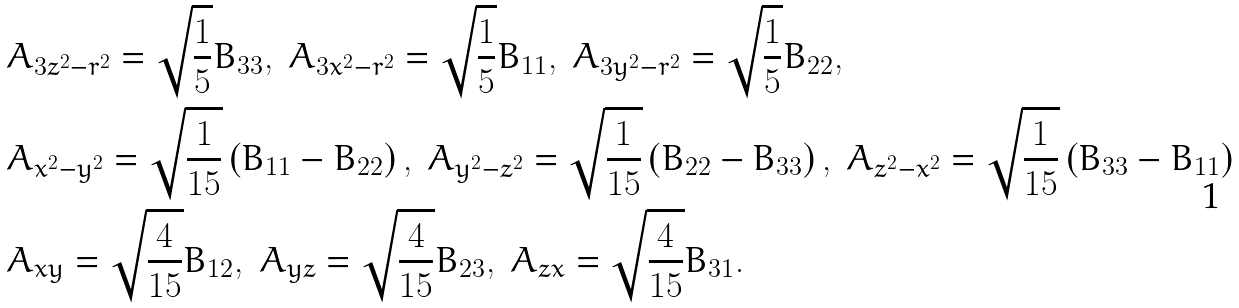<formula> <loc_0><loc_0><loc_500><loc_500>& A _ { 3 z ^ { 2 } - r ^ { 2 } } = \sqrt { \frac { 1 } { 5 } } B _ { 3 3 } , \ A _ { 3 x ^ { 2 } - r ^ { 2 } } = \sqrt { \frac { 1 } { 5 } } B _ { 1 1 } , \ A _ { 3 y ^ { 2 } - r ^ { 2 } } = \sqrt { \frac { 1 } { 5 } } B _ { 2 2 } , \\ & A _ { x ^ { 2 } - y ^ { 2 } } = \sqrt { \frac { 1 } { 1 5 } } \left ( B _ { 1 1 } - B _ { 2 2 } \right ) , \ A _ { y ^ { 2 } - z ^ { 2 } } = \sqrt { \frac { 1 } { 1 5 } } \left ( B _ { 2 2 } - B _ { 3 3 } \right ) , \ A _ { z ^ { 2 } - x ^ { 2 } } = \sqrt { \frac { 1 } { 1 5 } } \left ( B _ { 3 3 } - B _ { 1 1 } \right ) \\ & A _ { x y } = \sqrt { \frac { 4 } { 1 5 } } B _ { 1 2 } , \ A _ { y z } = \sqrt { \frac { 4 } { 1 5 } } B _ { 2 3 } , \ A _ { z x } = \sqrt { \frac { 4 } { 1 5 } } B _ { 3 1 } .</formula> 